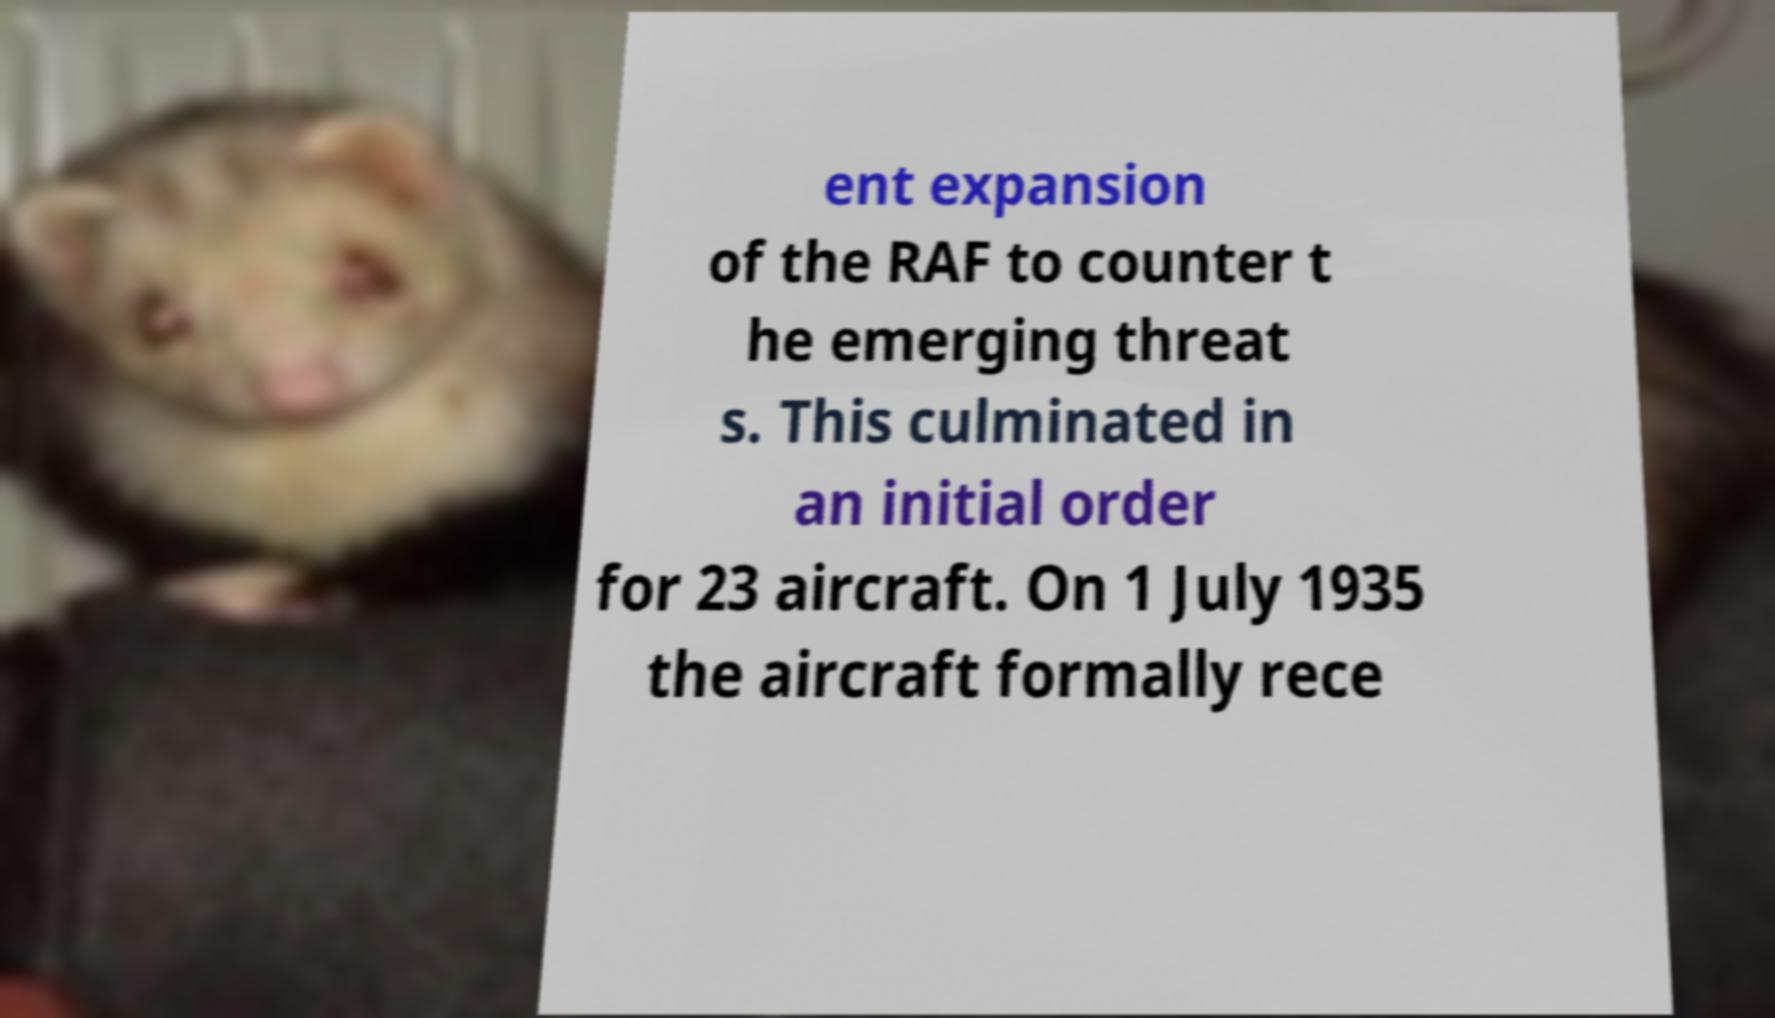There's text embedded in this image that I need extracted. Can you transcribe it verbatim? ent expansion of the RAF to counter t he emerging threat s. This culminated in an initial order for 23 aircraft. On 1 July 1935 the aircraft formally rece 